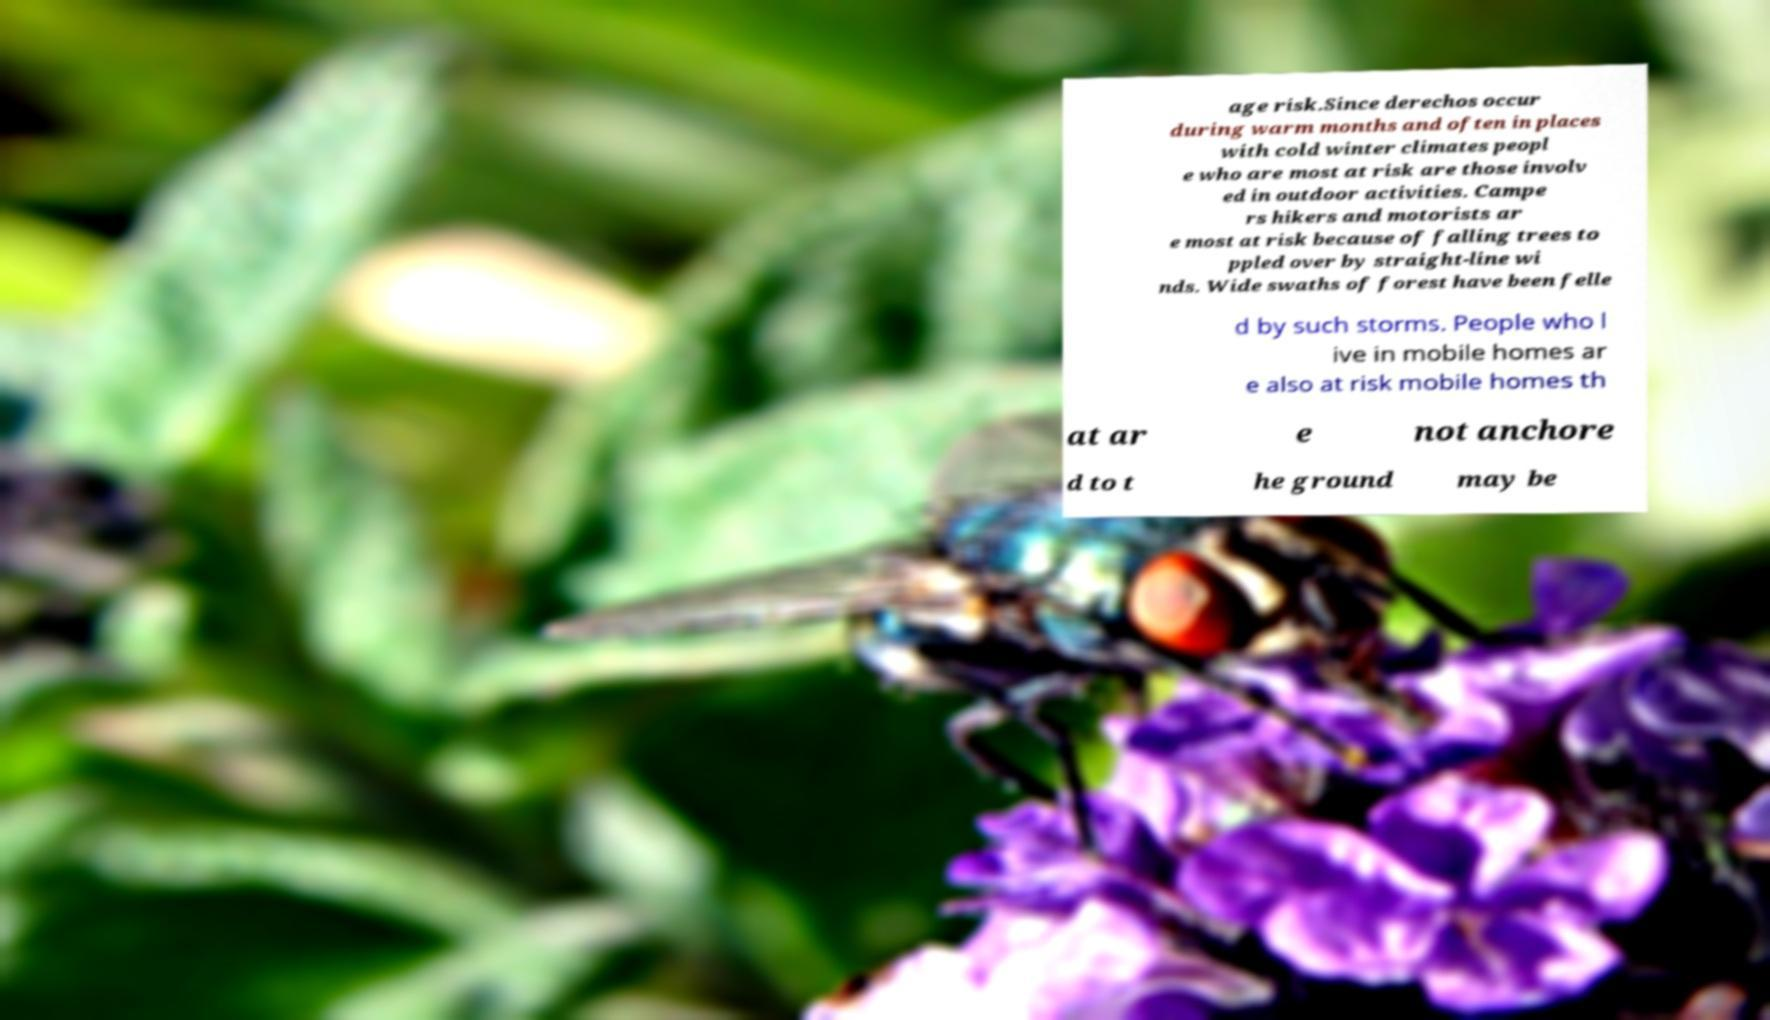I need the written content from this picture converted into text. Can you do that? age risk.Since derechos occur during warm months and often in places with cold winter climates peopl e who are most at risk are those involv ed in outdoor activities. Campe rs hikers and motorists ar e most at risk because of falling trees to ppled over by straight-line wi nds. Wide swaths of forest have been felle d by such storms. People who l ive in mobile homes ar e also at risk mobile homes th at ar e not anchore d to t he ground may be 